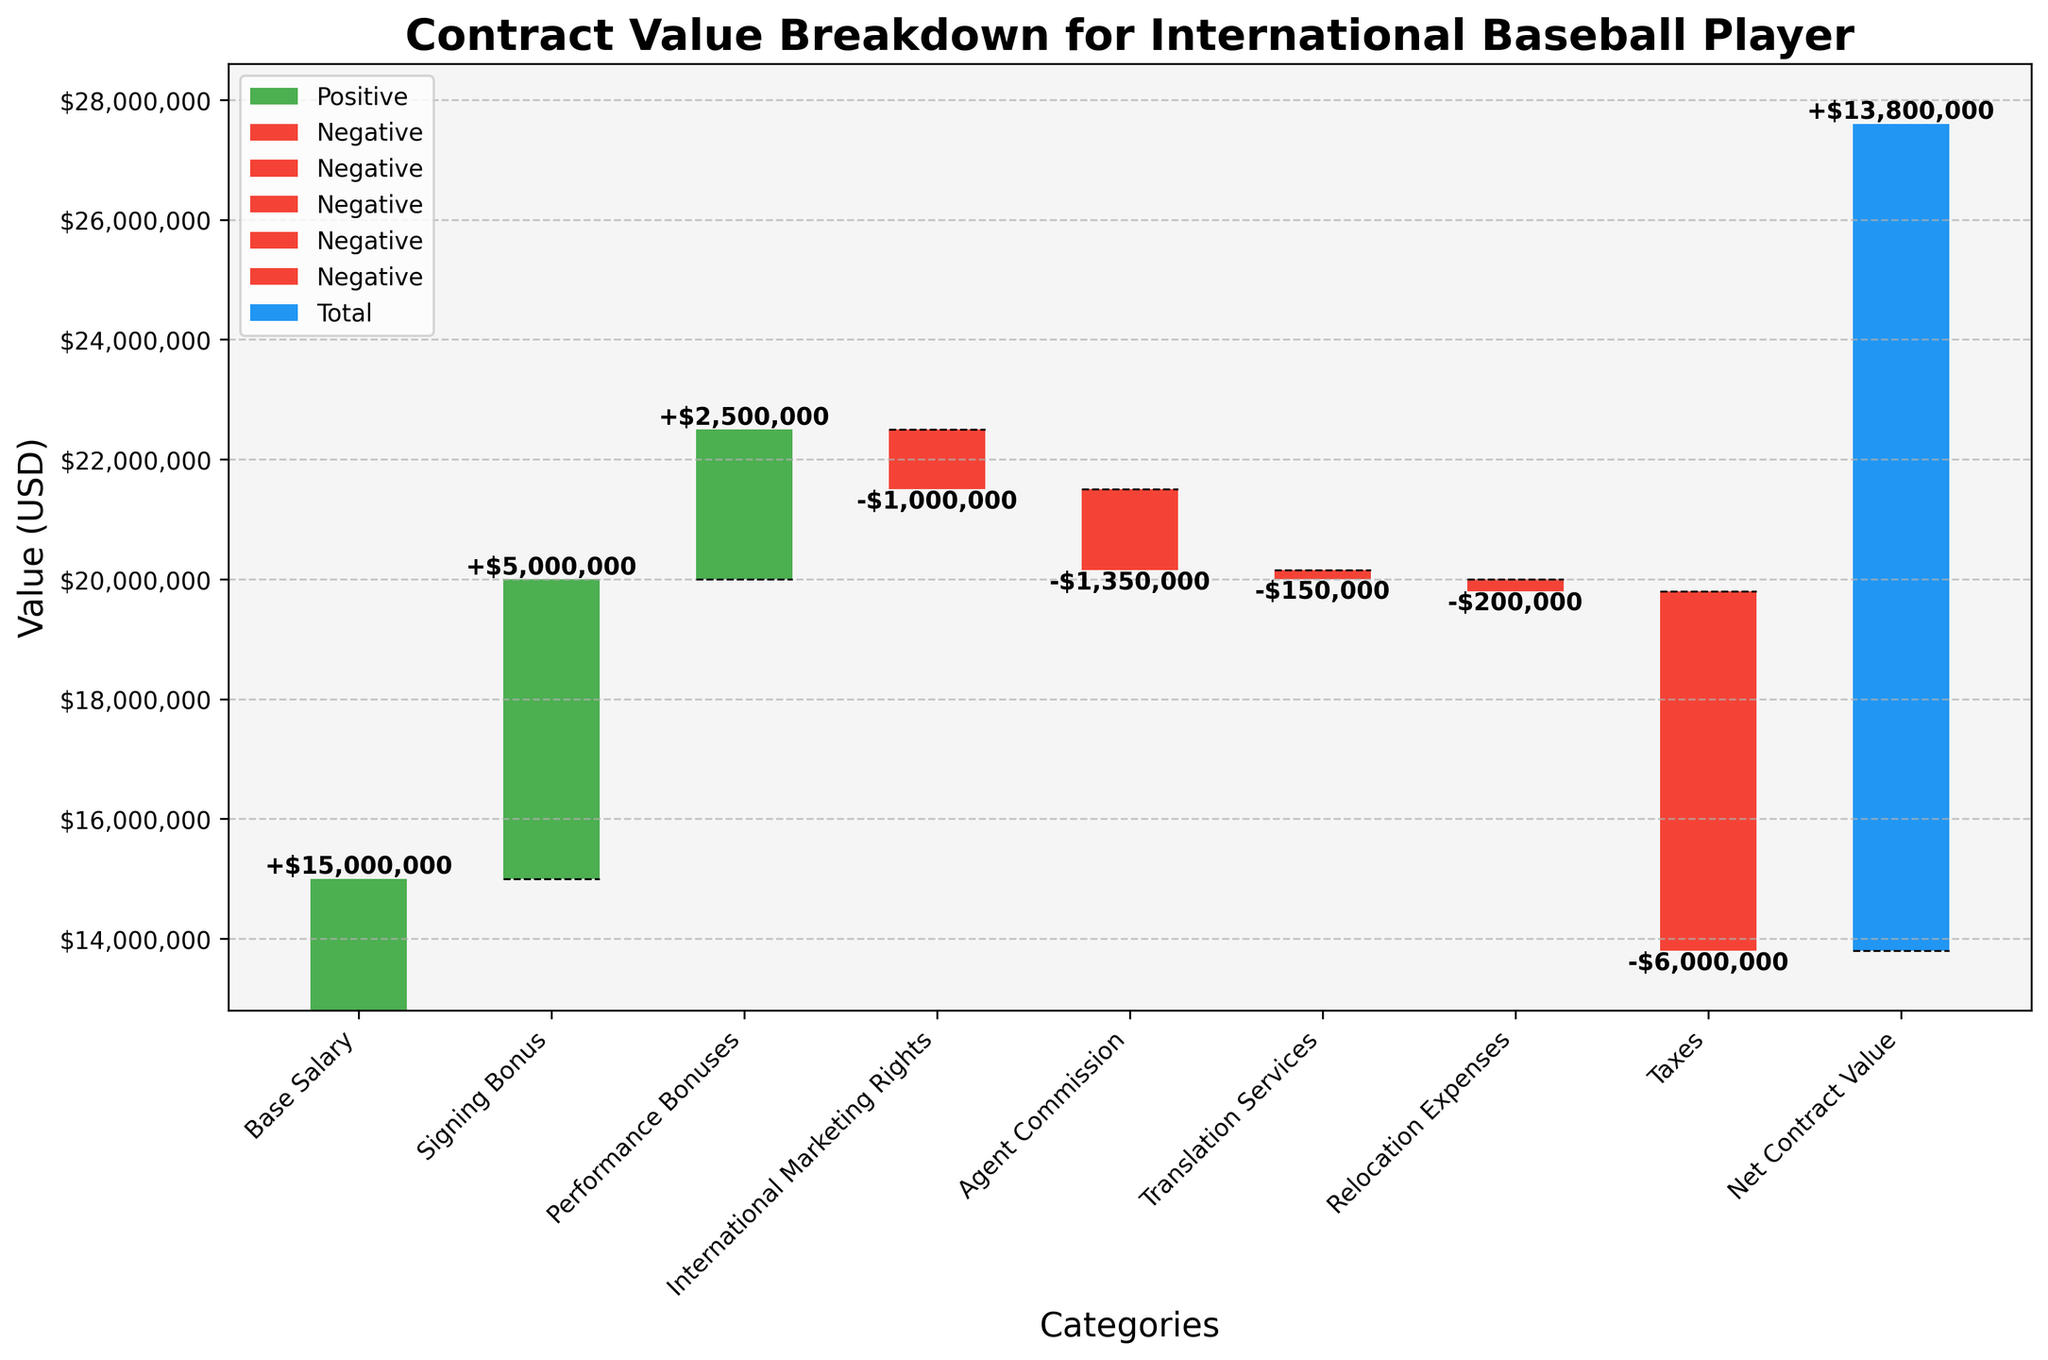What's the title of the chart? The title of the chart is displayed at the top and reads "Contract Value Breakdown for International Baseball Player".
Answer: Contract Value Breakdown for International Baseball Player How many categories are there in the waterfall chart? The chart lists each category on the x-axis. By counting them, we find there are 9 categories.
Answer: 9 Which category contributes the most positively to the contract value? By looking at the bar heights, the "Base Salary" contributes the most positively with a value of $15,000,000.
Answer: Base Salary What's the value of the signing bonus? The bar labeled "Signing Bonus" shows a value of $5,000,000 as indicated by the bar height and corresponding text annotation.
Answer: $5,000,000 What is the net contract value? The net contract value is shown by the final bar on the far right, which has a label indicating a value of $13,800,000.
Answer: $13,800,000 Which categories decrease the contract value? Categories with red bars decrease the contract value: "International Marketing Rights", "Agent Commission", "Translation Services", "Relocation Expenses", and "Taxes".
Answer: International Marketing Rights, Agent Commission, Translation Services, Relocation Expenses, Taxes How much is deducted from the contract value for taxes? The bar labeled "Taxes" shows a decrease of $6,000,000, reflected by its height and text annotation in red.
Answer: $6,000,000 What is the cumulative value after adding Performance Bonuses and subtracting International Marketing Rights? Adding the Performance Bonuses of $2,500,000 to the cumulative value before them ($20,000,000 post-Signing Bonus) results in $22,500,000. Subtracting International Marketing Rights of $-1,000,000 then gives a cumulative value of $21,500,000.
Answer: $21,500,000 Which expense is larger: Agent Commission or Relocation Expenses? The bar for "Agent Commission" shows a value of $-1,350,000, whereas "Relocation Expenses" shows a value of $-200,000. Comparing these, the Agent Commission is larger.
Answer: Agent Commission How do the Translation Services and Relocation Expenses affect the net contract value? Both "Translation Services" and "Relocation Expenses" are red bars, indicating they decrease the net contract value. Translation Services deduct $150,000, and Relocation Expenses deduct $200,000. Together, they reduce the net value by $350,000.
Answer: Decrease by $350,000 